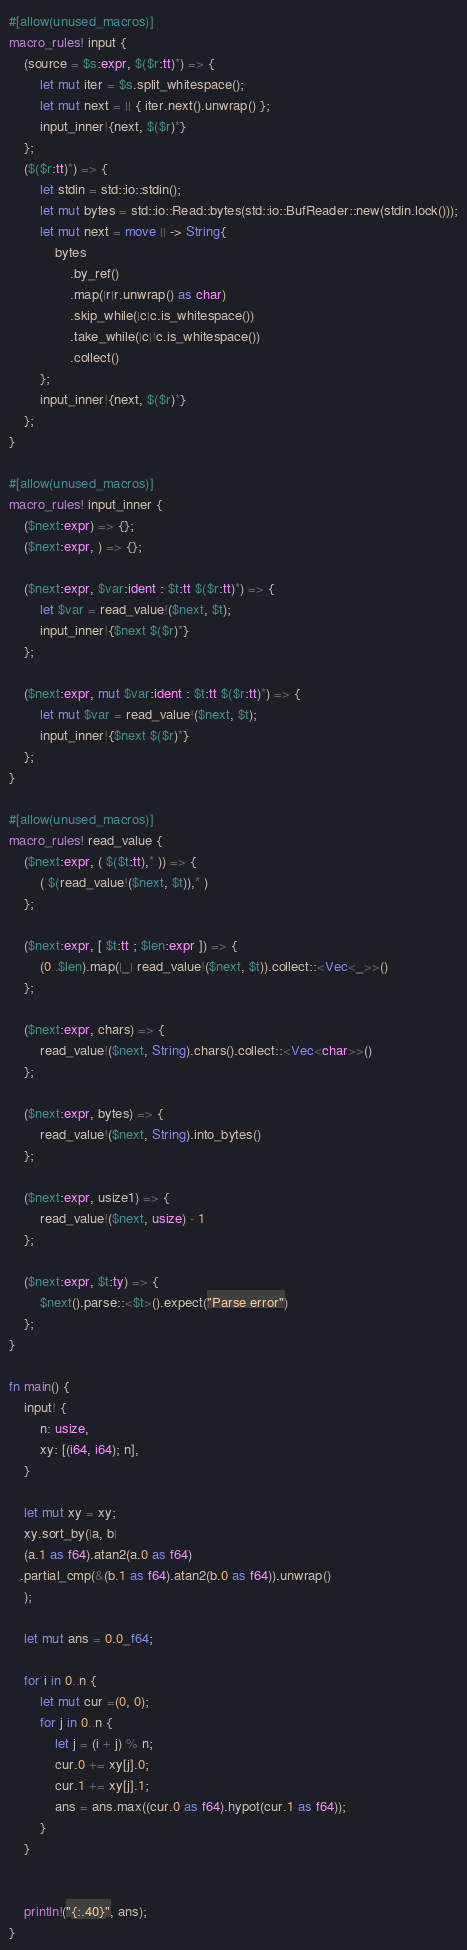Convert code to text. <code><loc_0><loc_0><loc_500><loc_500><_Rust_>#[allow(unused_macros)]
macro_rules! input {
    (source = $s:expr, $($r:tt)*) => {
        let mut iter = $s.split_whitespace();
        let mut next = || { iter.next().unwrap() };
        input_inner!{next, $($r)*}
    };
    ($($r:tt)*) => {
        let stdin = std::io::stdin();
        let mut bytes = std::io::Read::bytes(std::io::BufReader::new(stdin.lock()));
        let mut next = move || -> String{
            bytes
                .by_ref()
                .map(|r|r.unwrap() as char)
                .skip_while(|c|c.is_whitespace())
                .take_while(|c|!c.is_whitespace())
                .collect()
        };
        input_inner!{next, $($r)*}
    };
}

#[allow(unused_macros)]
macro_rules! input_inner {
    ($next:expr) => {};
    ($next:expr, ) => {};

    ($next:expr, $var:ident : $t:tt $($r:tt)*) => {
        let $var = read_value!($next, $t);
        input_inner!{$next $($r)*}
    };

    ($next:expr, mut $var:ident : $t:tt $($r:tt)*) => {
        let mut $var = read_value!($next, $t);
        input_inner!{$next $($r)*}
    };
}

#[allow(unused_macros)]
macro_rules! read_value {
    ($next:expr, ( $($t:tt),* )) => {
        ( $(read_value!($next, $t)),* )
    };

    ($next:expr, [ $t:tt ; $len:expr ]) => {
        (0..$len).map(|_| read_value!($next, $t)).collect::<Vec<_>>()
    };

    ($next:expr, chars) => {
        read_value!($next, String).chars().collect::<Vec<char>>()
    };

    ($next:expr, bytes) => {
        read_value!($next, String).into_bytes()
    };

    ($next:expr, usize1) => {
        read_value!($next, usize) - 1
    };

    ($next:expr, $t:ty) => {
        $next().parse::<$t>().expect("Parse error")
    };
}

fn main() {
    input! {
        n: usize,
        xy: [(i64, i64); n],
    }

    let mut xy = xy;
    xy.sort_by(|a, b|
    (a.1 as f64).atan2(a.0 as f64)
   .partial_cmp(&(b.1 as f64).atan2(b.0 as f64)).unwrap()
    );

    let mut ans = 0.0_f64;

    for i in 0..n {
        let mut cur =(0, 0);
        for j in 0..n {
            let j = (i + j) % n;
            cur.0 += xy[j].0;
            cur.1 += xy[j].1;
            ans = ans.max((cur.0 as f64).hypot(cur.1 as f64));
        }
    }


    println!("{:.40}", ans);
}
</code> 